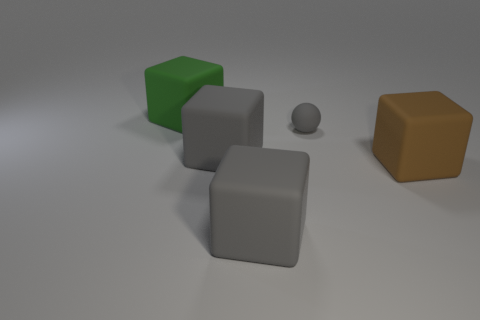There is a rubber cube in front of the large matte cube that is on the right side of the small gray rubber ball; what is its size?
Provide a succinct answer. Large. There is a large rubber cube in front of the brown cube; is it the same color as the small matte ball?
Make the answer very short. Yes. Are there any other big green rubber things that have the same shape as the green matte object?
Give a very brief answer. No. What is the size of the matte thing that is behind the matte sphere?
Make the answer very short. Large. There is a thing right of the small thing; are there any small gray objects that are right of it?
Make the answer very short. No. Is the material of the thing that is to the right of the small matte thing the same as the big green block?
Your answer should be very brief. Yes. What number of big matte things are both to the left of the brown thing and in front of the large green block?
Keep it short and to the point. 2. How many green cylinders are the same material as the big brown thing?
Your answer should be very brief. 0. There is a small sphere that is made of the same material as the large green object; what color is it?
Your answer should be compact. Gray. Are there fewer gray things than large cyan spheres?
Ensure brevity in your answer.  No. 